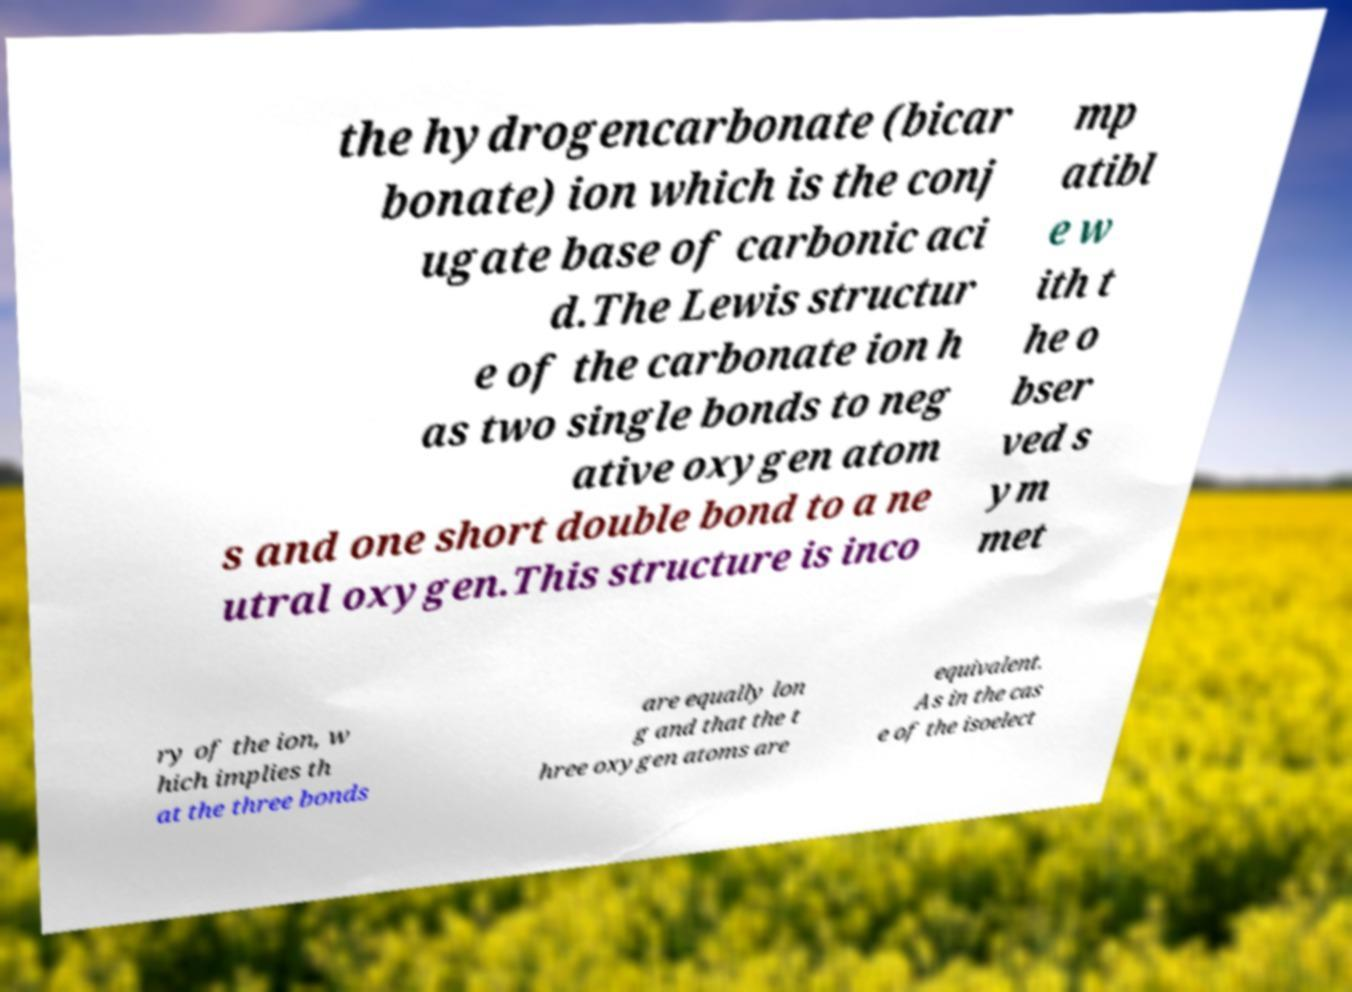Could you assist in decoding the text presented in this image and type it out clearly? the hydrogencarbonate (bicar bonate) ion which is the conj ugate base of carbonic aci d.The Lewis structur e of the carbonate ion h as two single bonds to neg ative oxygen atom s and one short double bond to a ne utral oxygen.This structure is inco mp atibl e w ith t he o bser ved s ym met ry of the ion, w hich implies th at the three bonds are equally lon g and that the t hree oxygen atoms are equivalent. As in the cas e of the isoelect 